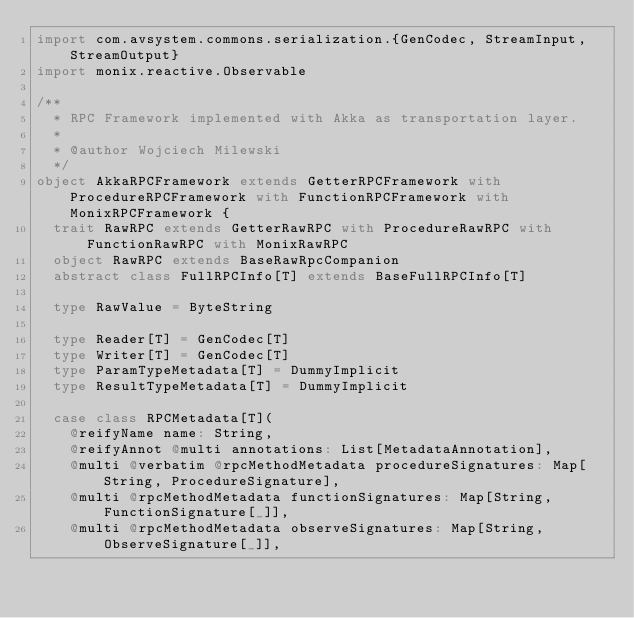Convert code to text. <code><loc_0><loc_0><loc_500><loc_500><_Scala_>import com.avsystem.commons.serialization.{GenCodec, StreamInput, StreamOutput}
import monix.reactive.Observable

/**
  * RPC Framework implemented with Akka as transportation layer.
  *
  * @author Wojciech Milewski
  */
object AkkaRPCFramework extends GetterRPCFramework with ProcedureRPCFramework with FunctionRPCFramework with MonixRPCFramework {
  trait RawRPC extends GetterRawRPC with ProcedureRawRPC with FunctionRawRPC with MonixRawRPC
  object RawRPC extends BaseRawRpcCompanion
  abstract class FullRPCInfo[T] extends BaseFullRPCInfo[T]

  type RawValue = ByteString

  type Reader[T] = GenCodec[T]
  type Writer[T] = GenCodec[T]
  type ParamTypeMetadata[T] = DummyImplicit
  type ResultTypeMetadata[T] = DummyImplicit

  case class RPCMetadata[T](
    @reifyName name: String,
    @reifyAnnot @multi annotations: List[MetadataAnnotation],
    @multi @verbatim @rpcMethodMetadata procedureSignatures: Map[String, ProcedureSignature],
    @multi @rpcMethodMetadata functionSignatures: Map[String, FunctionSignature[_]],
    @multi @rpcMethodMetadata observeSignatures: Map[String, ObserveSignature[_]],</code> 